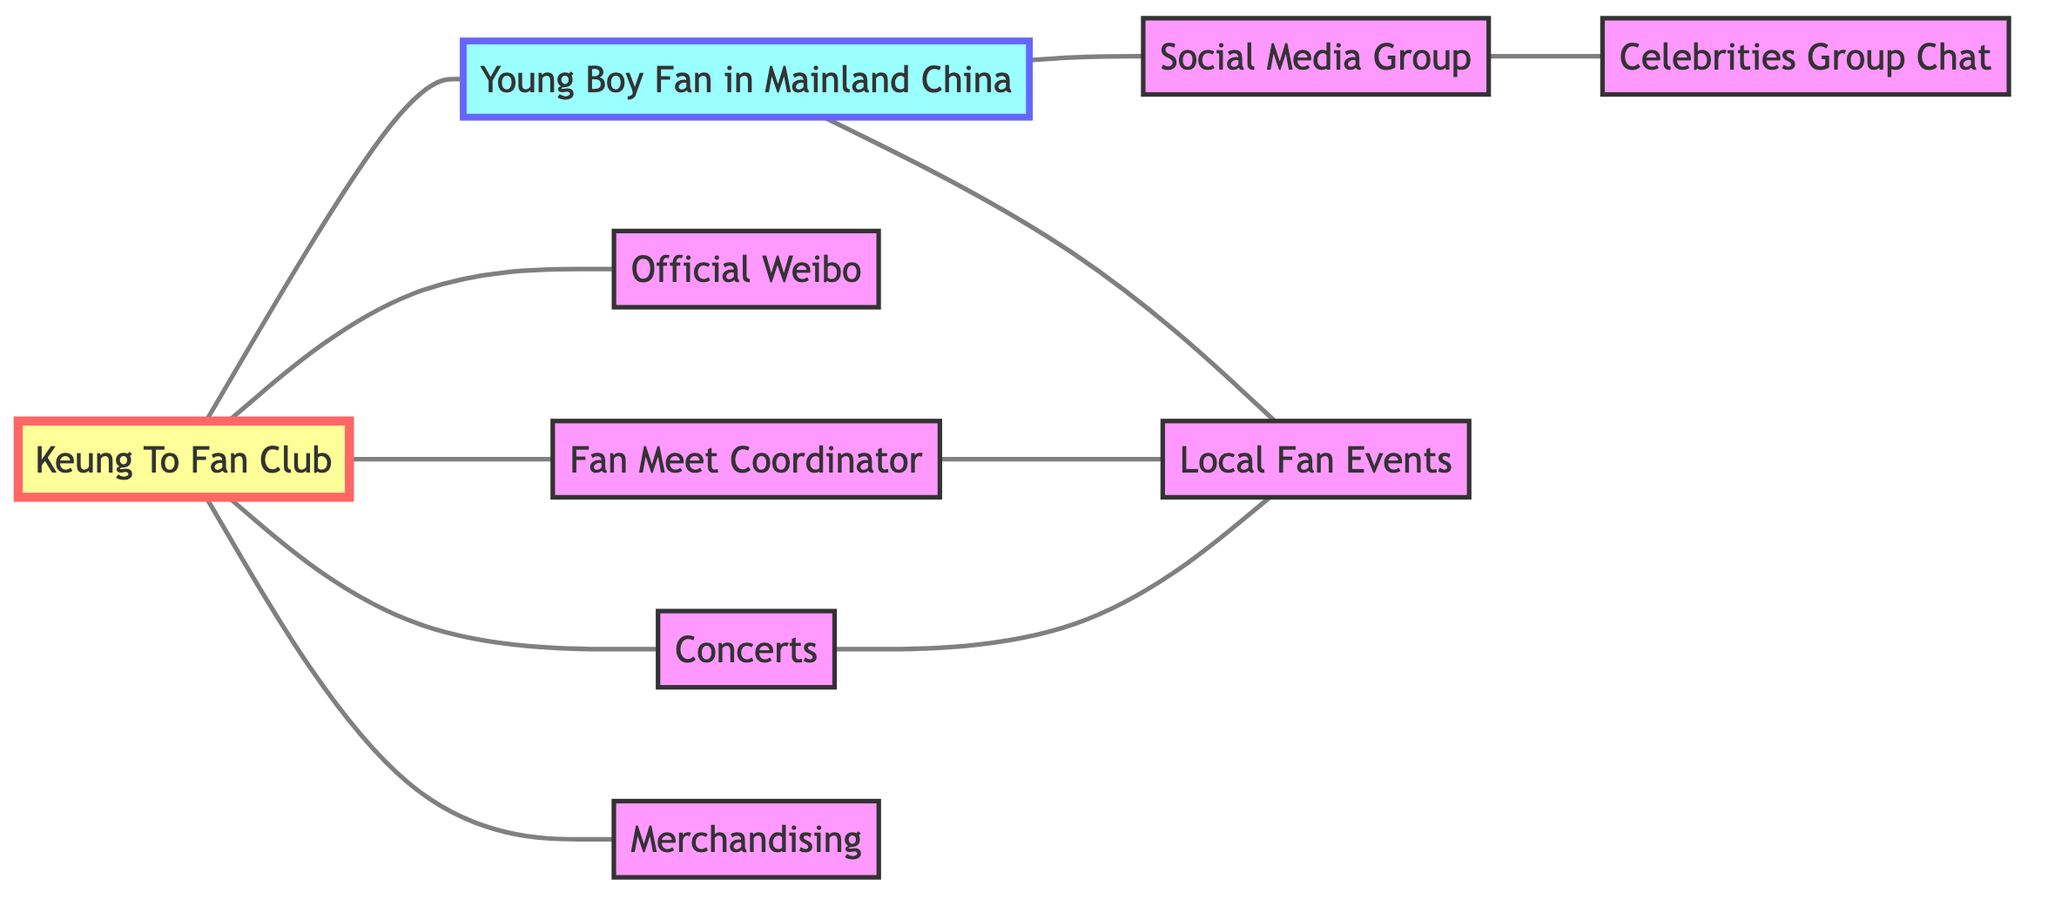What's the total number of nodes in the graph? The diagram lists 8 different nodes, which can be counted directly: Keung To Fan Club, Young Boy Fan in Mainland China, Official Weibo, Fan Meet Coordinator, Concerts, Merchandising, Celebrities Group Chat, and Social Media Group.
Answer: 8 How many edges are there connecting the nodes? By examining the diagram, I can count that there are 10 edges. Each connection between nodes counts as an edge, and they include various relationships such as between the fan club and local fans or events.
Answer: 10 Which node is the coordinator of fan meet events? Looking at the connections, the node labeled "Fan Meet Coordinator" directly connects to "Local Fan Events," indicating that this node is responsible for coordinating those events.
Answer: Fan Meet Coordinator What are the connections of the "Boy Local Fan" node? The "Boy Local Fan" node connects to three other nodes: "Keung To Fan Club," "Social Media Group," and "Local Fan Events." These connections show his involvement in various social aspects of the fan club.
Answer: Keung To Fan Club, Social Media Group, Local Fan Events Which nodes are directly related to the "Concerts"? The "Concerts" node is directly connected to two nodes: "Keung To Fan Club" and "Local Fan Events." This indicates its significance in the context of fan activities.
Answer: Keung To Fan Club, Local Fan Events How does the "Social Media Group" relate to the "Celebrities Group Chat"? There is a direct connection (edge) between the "Social Media Group" and "Celebrities Group Chat," suggesting a communication or shared platform between these two groups.
Answer: Yes Which node serves as the official social media presence for the fan club? The "Official Weibo" node serves as the official social media presence, connecting directly to the "Keung To Fan Club," thus indicating their online presence.
Answer: Official Weibo Is there a node that connects both "Concerts" and "Local Fan Events"? Yes, there is an edge between "Concerts" and "Local Fan Events," showing that concerts are related to and likely influence local fan events in the city.
Answer: Yes 